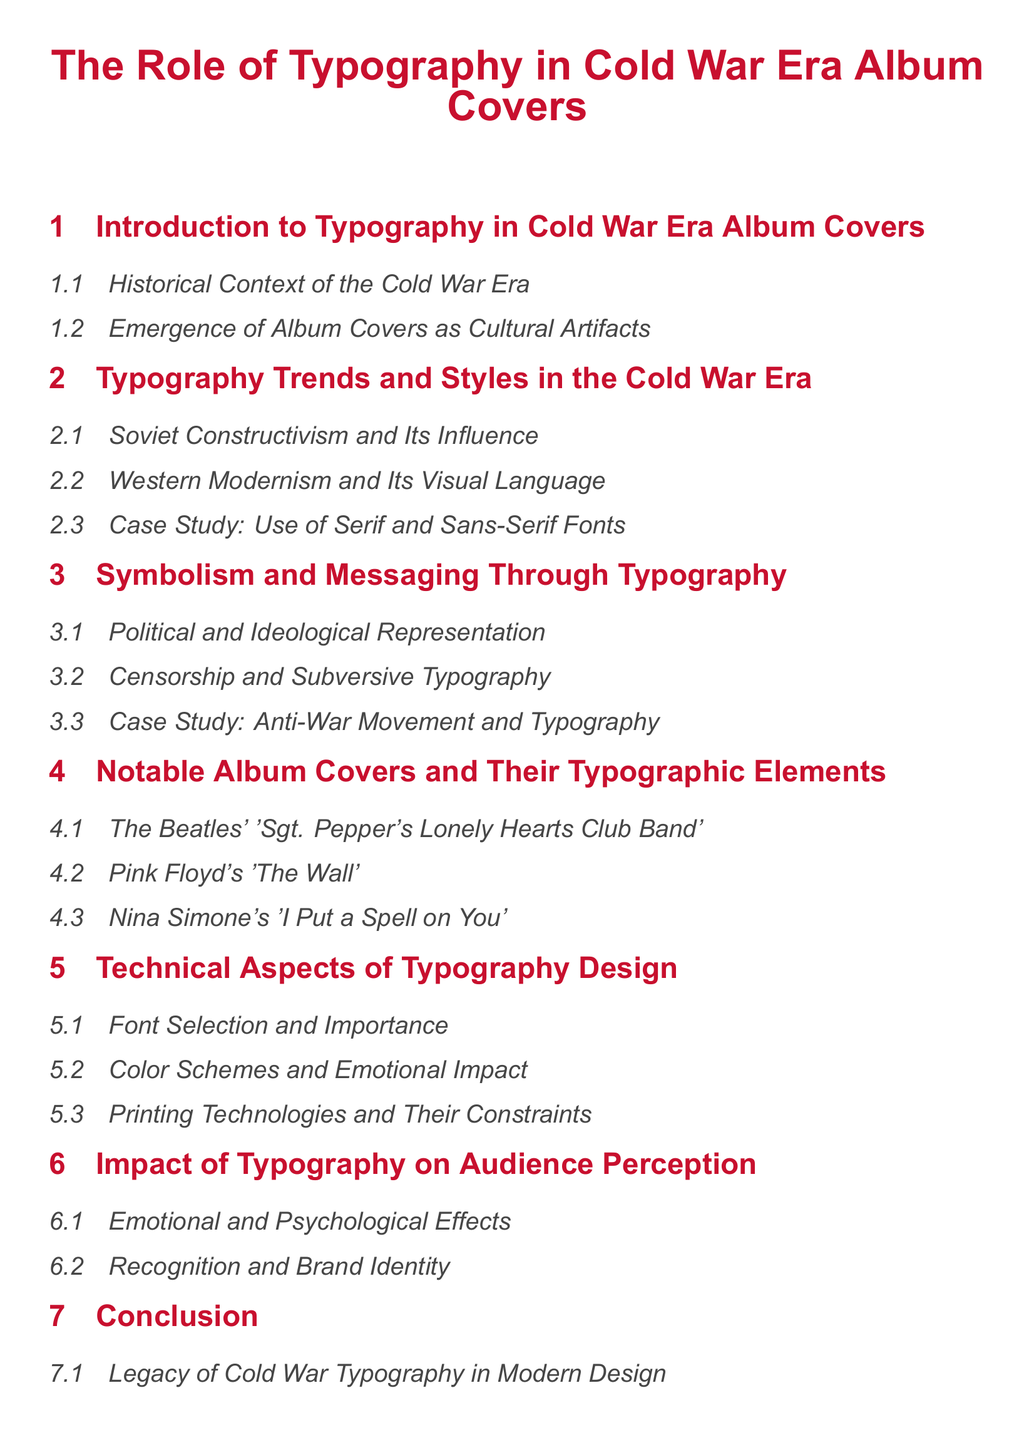What is the title of the document? The title of the document is provided at the beginning, reflecting the main focus on typography in album covers during the Cold War era.
Answer: The Role of Typography in Cold War Era Album Covers How many main sections are in the document? The document is structured with six main sections, each covering different aspects of typography in album covers.
Answer: 6 Which color is used for the main title? The color used for the main title is specified in the document, giving it a distinctive look that ties to the theme.
Answer: Soviet red What is a case study mentioned under typography trends? A specific case study exemplifying the use of typography is included, showcasing the application of styles in a notable example.
Answer: Use of Serif and Sans-Serif Fonts Which notable album cover is discussed first? The first notable album cover mentioned highlights a classic example of album design, illustrating the era's cultural significance.
Answer: The Beatles' 'Sgt. Pepper's Lonely Hearts Club Band' What aspect of typography design is emphasized in the technical section? The technical aspects cover several key elements necessary for effective typography, emphasizing the importance of a specific element.
Answer: Font Selection Which sub-section focuses on the emotional effects of typography? The emotional and psychological effects of typography are discussed in a sub-section that relates to audience perception.
Answer: Emotional and Psychological Effects How does the document categorize the influence of typography today? The conclusion discusses how the legacy of typography from the Cold War era continues to resonate in modern design practices.
Answer: Continued Influence on Contemporary Album Covers 